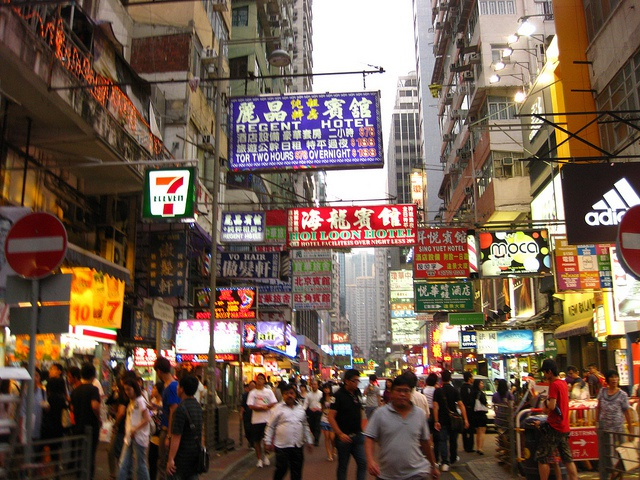Describe the objects in this image and their specific colors. I can see people in black, maroon, olive, and gray tones, people in black, gray, and maroon tones, people in black, maroon, and navy tones, people in black, darkgray, gray, and maroon tones, and people in black and maroon tones in this image. 